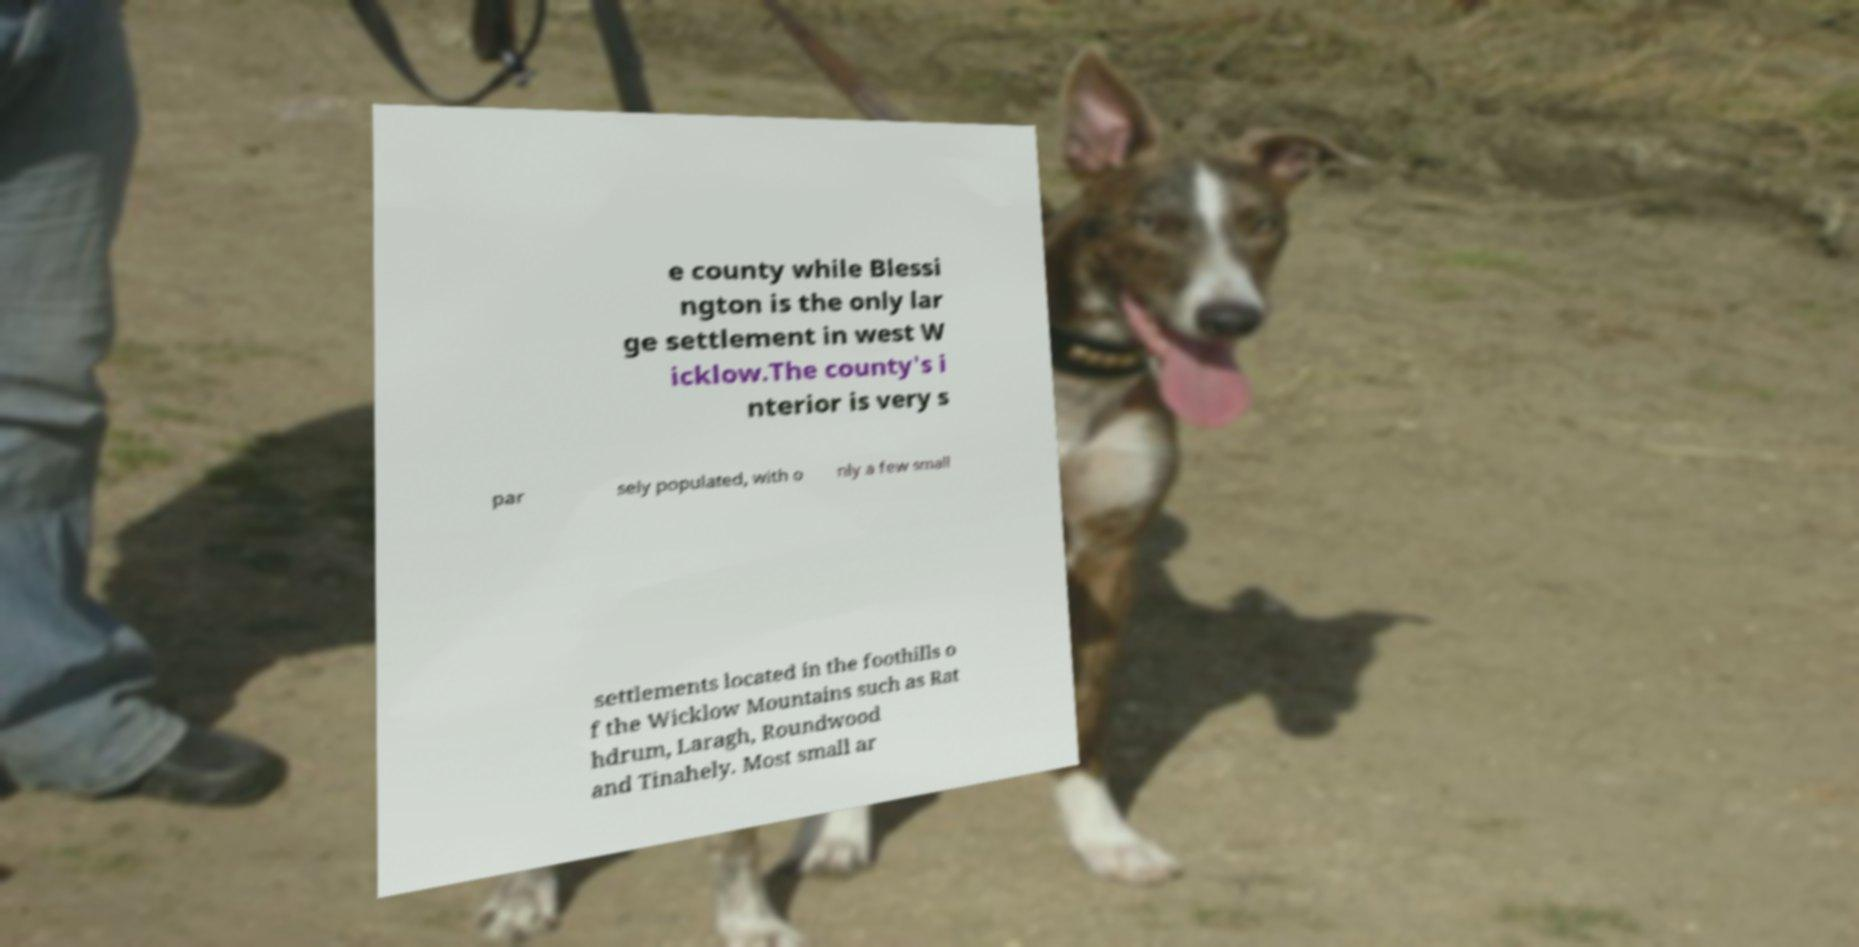Please identify and transcribe the text found in this image. e county while Blessi ngton is the only lar ge settlement in west W icklow.The county's i nterior is very s par sely populated, with o nly a few small settlements located in the foothills o f the Wicklow Mountains such as Rat hdrum, Laragh, Roundwood and Tinahely. Most small ar 